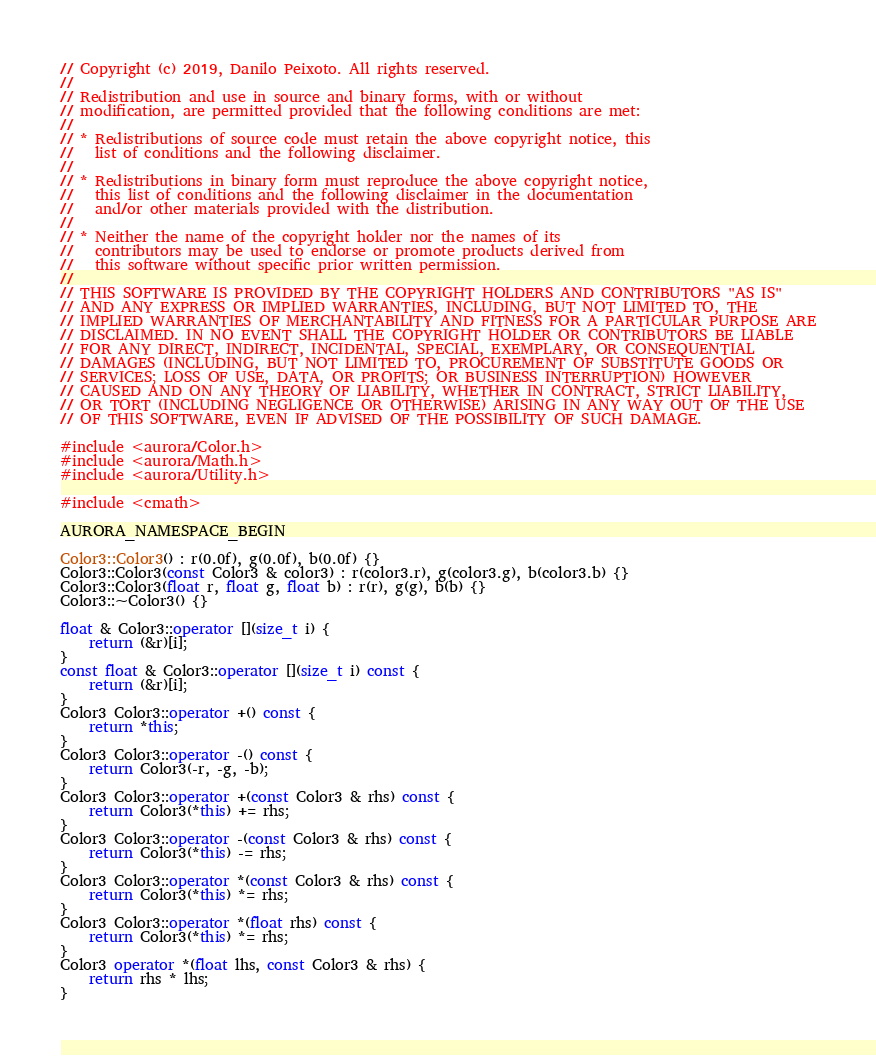<code> <loc_0><loc_0><loc_500><loc_500><_C++_>// Copyright (c) 2019, Danilo Peixoto. All rights reserved.
//
// Redistribution and use in source and binary forms, with or without
// modification, are permitted provided that the following conditions are met:
//
// * Redistributions of source code must retain the above copyright notice, this
//   list of conditions and the following disclaimer.
//
// * Redistributions in binary form must reproduce the above copyright notice,
//   this list of conditions and the following disclaimer in the documentation
//   and/or other materials provided with the distribution.
//
// * Neither the name of the copyright holder nor the names of its
//   contributors may be used to endorse or promote products derived from
//   this software without specific prior written permission.
//
// THIS SOFTWARE IS PROVIDED BY THE COPYRIGHT HOLDERS AND CONTRIBUTORS "AS IS"
// AND ANY EXPRESS OR IMPLIED WARRANTIES, INCLUDING, BUT NOT LIMITED TO, THE
// IMPLIED WARRANTIES OF MERCHANTABILITY AND FITNESS FOR A PARTICULAR PURPOSE ARE
// DISCLAIMED. IN NO EVENT SHALL THE COPYRIGHT HOLDER OR CONTRIBUTORS BE LIABLE
// FOR ANY DIRECT, INDIRECT, INCIDENTAL, SPECIAL, EXEMPLARY, OR CONSEQUENTIAL
// DAMAGES (INCLUDING, BUT NOT LIMITED TO, PROCUREMENT OF SUBSTITUTE GOODS OR
// SERVICES; LOSS OF USE, DATA, OR PROFITS; OR BUSINESS INTERRUPTION) HOWEVER
// CAUSED AND ON ANY THEORY OF LIABILITY, WHETHER IN CONTRACT, STRICT LIABILITY,
// OR TORT (INCLUDING NEGLIGENCE OR OTHERWISE) ARISING IN ANY WAY OUT OF THE USE
// OF THIS SOFTWARE, EVEN IF ADVISED OF THE POSSIBILITY OF SUCH DAMAGE.

#include <aurora/Color.h>
#include <aurora/Math.h>
#include <aurora/Utility.h>

#include <cmath>

AURORA_NAMESPACE_BEGIN

Color3::Color3() : r(0.0f), g(0.0f), b(0.0f) {}
Color3::Color3(const Color3 & color3) : r(color3.r), g(color3.g), b(color3.b) {}
Color3::Color3(float r, float g, float b) : r(r), g(g), b(b) {}
Color3::~Color3() {}

float & Color3::operator [](size_t i) {
    return (&r)[i];
}
const float & Color3::operator [](size_t i) const {
    return (&r)[i];
}
Color3 Color3::operator +() const {
    return *this;
}
Color3 Color3::operator -() const {
    return Color3(-r, -g, -b);
}
Color3 Color3::operator +(const Color3 & rhs) const {
    return Color3(*this) += rhs;
}
Color3 Color3::operator -(const Color3 & rhs) const {
    return Color3(*this) -= rhs;
}
Color3 Color3::operator *(const Color3 & rhs) const {
    return Color3(*this) *= rhs;
}
Color3 Color3::operator *(float rhs) const {
    return Color3(*this) *= rhs;
}
Color3 operator *(float lhs, const Color3 & rhs) {
    return rhs * lhs;
}</code> 